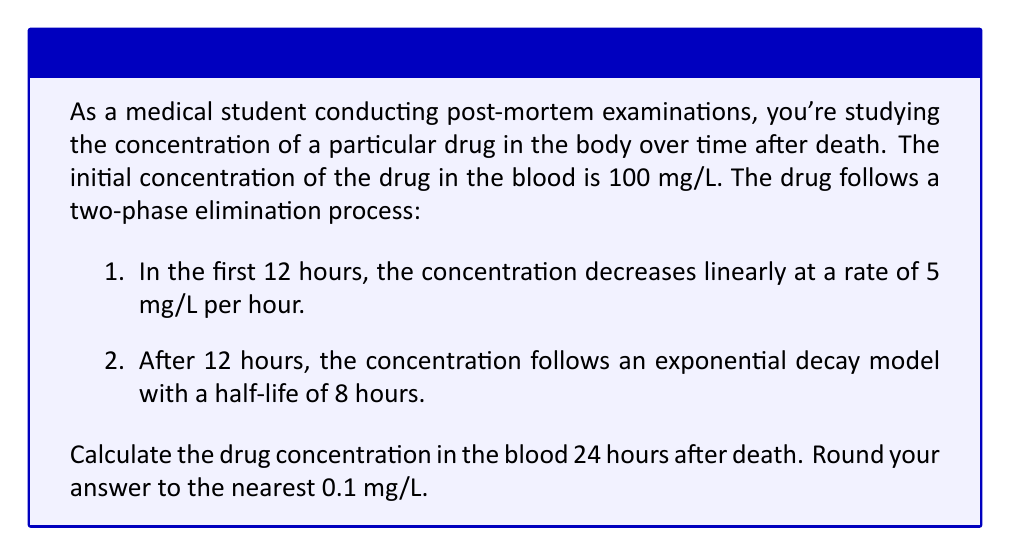Can you solve this math problem? Let's approach this problem in two phases:

Phase 1 (0-12 hours): Linear decrease
1. Initial concentration: $C_0 = 100$ mg/L
2. Rate of decrease: $r = 5$ mg/L per hour
3. Time: $t = 12$ hours

The linear function for the first 12 hours is:
$$C(t) = C_0 - rt = 100 - 5t$$

At $t = 12$ hours:
$$C(12) = 100 - 5(12) = 100 - 60 = 40$$ mg/L

Phase 2 (12-24 hours): Exponential decay
1. Initial concentration for this phase: $C_0 = 40$ mg/L
2. Half-life: $t_{1/2} = 8$ hours
3. Time: $t = 12$ hours (from hour 12 to hour 24)

The exponential decay function is:
$$C(t) = C_0 \cdot 2^{-t/t_{1/2}}$$

We need to calculate the decay constant $k$:
$$k = \frac{\ln(2)}{t_{1/2}} = \frac{\ln(2)}{8} \approx 0.0866$$

Now we can use the exponential decay formula:
$$C(t) = C_0 \cdot e^{-kt}$$

Plugging in our values:
$$C(12) = 40 \cdot e^{-0.0866 \cdot 12}$$
$$C(12) = 40 \cdot e^{-1.0392}$$
$$C(12) = 40 \cdot 0.3538$$
$$C(12) = 14.152$$ mg/L

Rounding to the nearest 0.1 mg/L, we get 14.2 mg/L.
Answer: 14.2 mg/L 